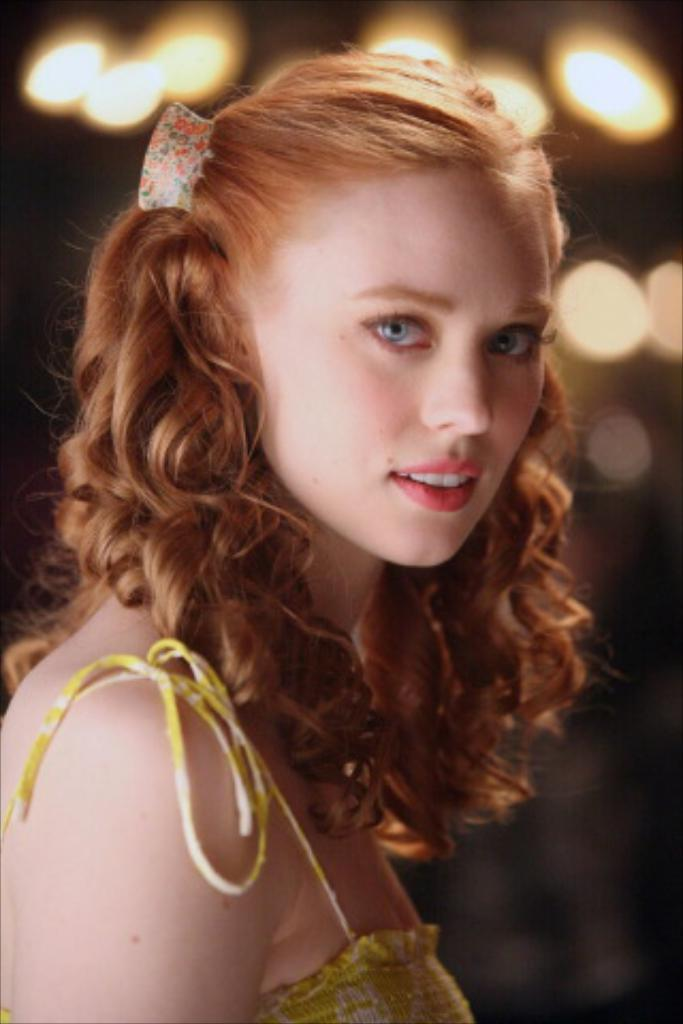Who is the main subject in the image? There is a woman in the image. What is the woman wearing? The woman is wearing a yellow dress. Can you describe the background of the image? The background of the image is blurry. What can be seen in the background of the image? There are lights visible in the background. What type of horn is being played by the woman in the image? There is no horn present in the image, and the woman is not playing any musical instrument. What material is the brass used for the woman's dress in the image? The woman's dress is yellow, but there is no mention of brass being used as a material in the dress. 